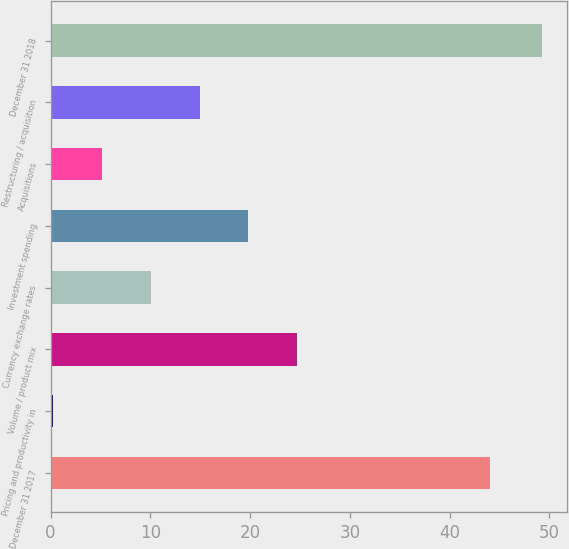Convert chart to OTSL. <chart><loc_0><loc_0><loc_500><loc_500><bar_chart><fcel>December 31 2017<fcel>Pricing and productivity in<fcel>Volume / product mix<fcel>Currency exchange rates<fcel>Investment spending<fcel>Acquisitions<fcel>Restructuring / acquisition<fcel>December 31 2018<nl><fcel>44.1<fcel>0.2<fcel>24.75<fcel>10.02<fcel>19.84<fcel>5.11<fcel>14.93<fcel>49.3<nl></chart> 